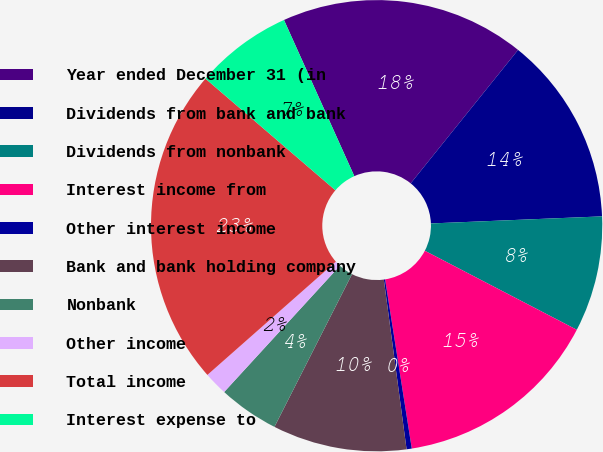<chart> <loc_0><loc_0><loc_500><loc_500><pie_chart><fcel>Year ended December 31 (in<fcel>Dividends from bank and bank<fcel>Dividends from nonbank<fcel>Interest income from<fcel>Other interest income<fcel>Bank and bank holding company<fcel>Nonbank<fcel>Other income<fcel>Total income<fcel>Interest expense to<nl><fcel>17.52%<fcel>13.56%<fcel>8.29%<fcel>14.88%<fcel>0.37%<fcel>9.6%<fcel>4.33%<fcel>1.69%<fcel>22.8%<fcel>6.97%<nl></chart> 